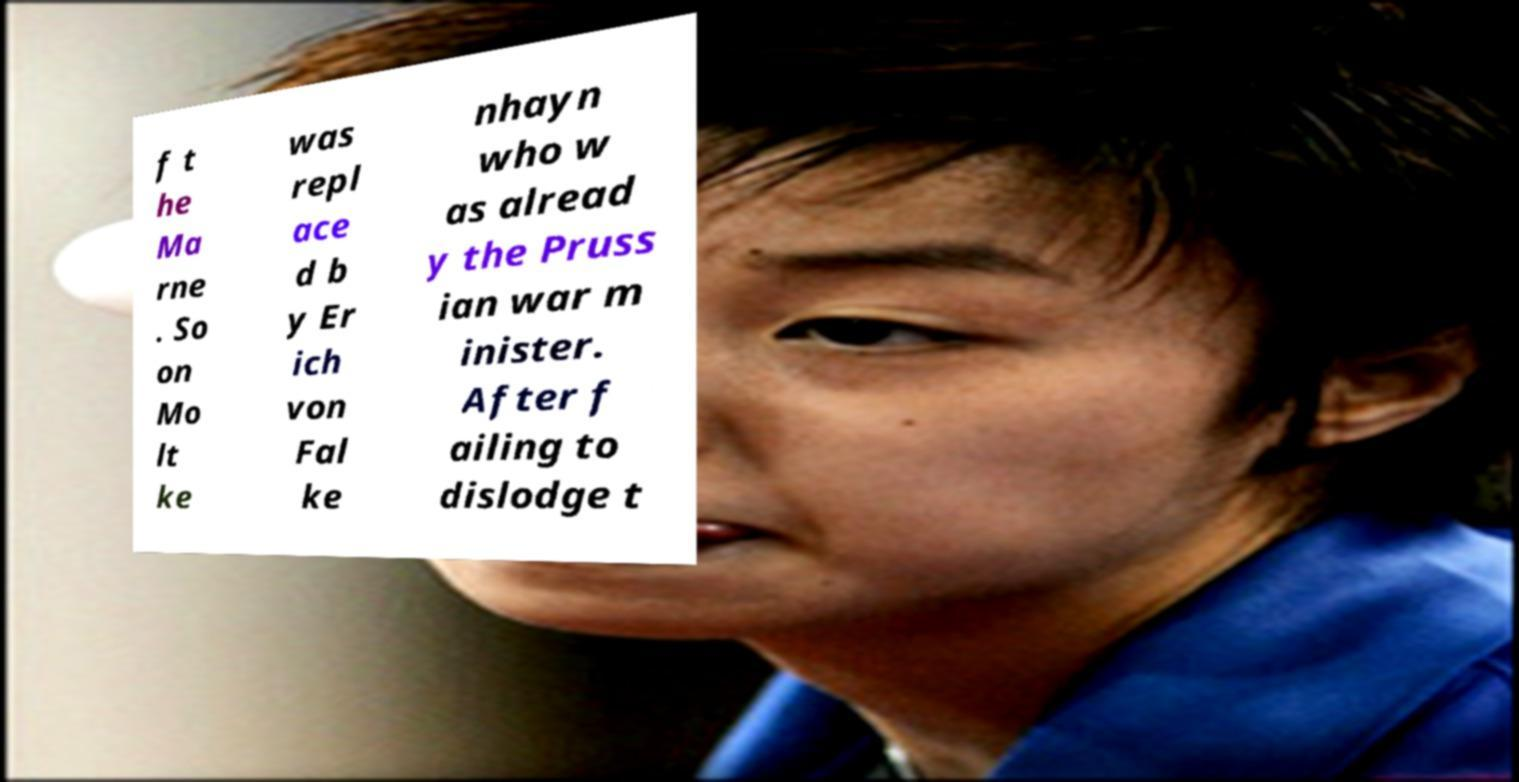Can you accurately transcribe the text from the provided image for me? f t he Ma rne . So on Mo lt ke was repl ace d b y Er ich von Fal ke nhayn who w as alread y the Pruss ian war m inister. After f ailing to dislodge t 